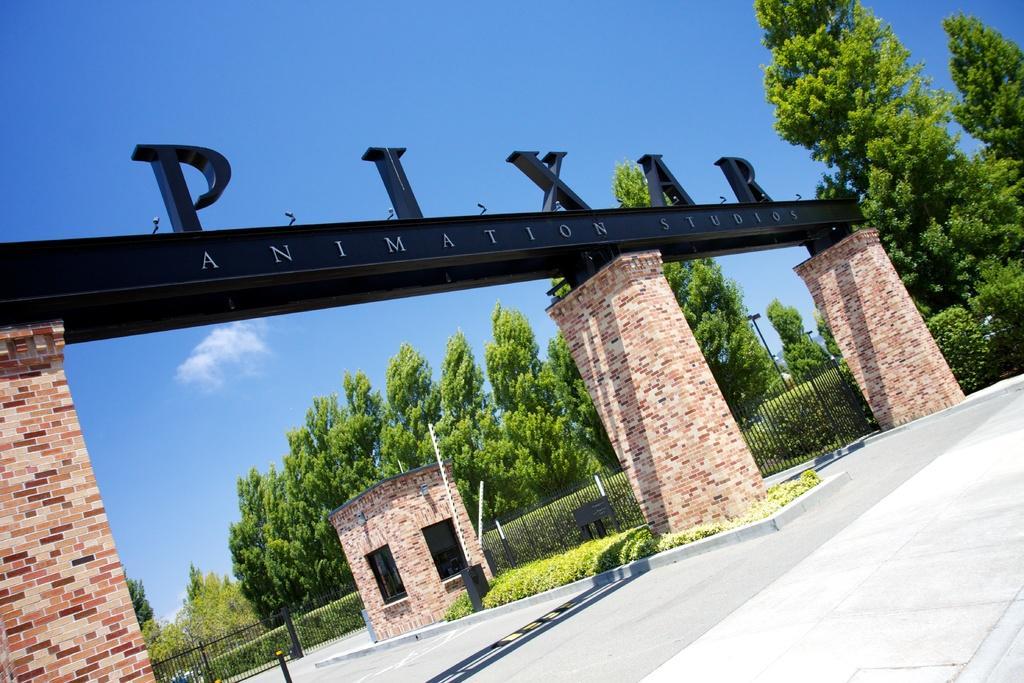Can you describe this image briefly? There are letters arranged on a platform, on which there is a text. This platform is on three pillars. There is a room having windows on the divider, on which there is grass. In the background are a fence, plants and grass and there are clouds in the blue sky. 